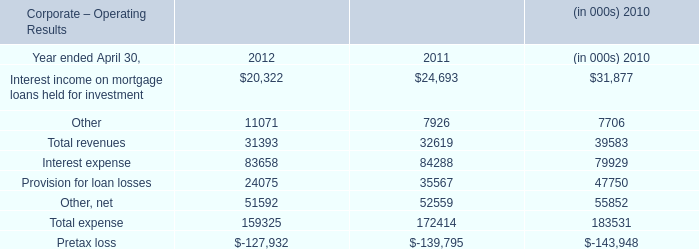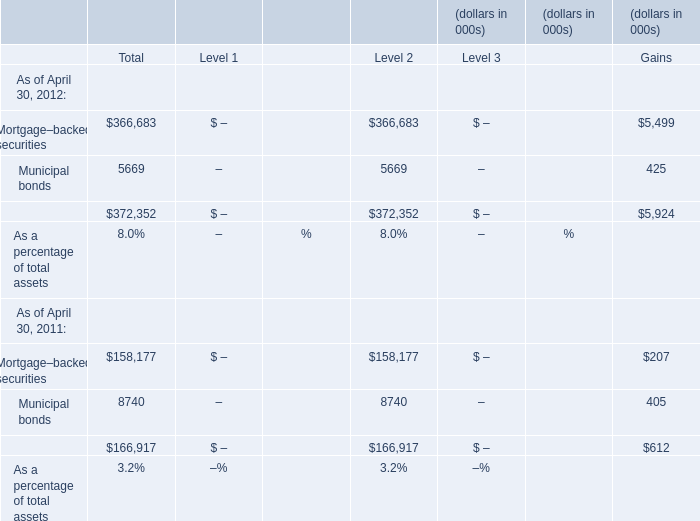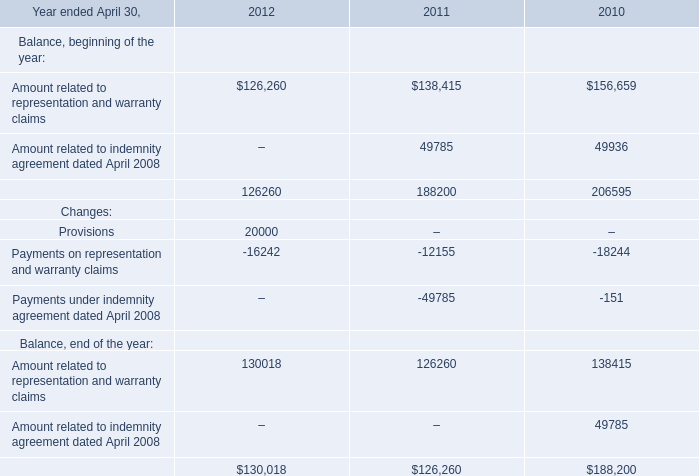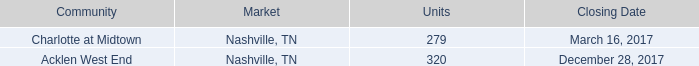what is the number of units necessary to stabilize the acklen west end community? 
Computations: (90% * 320)
Answer: 288.0. 